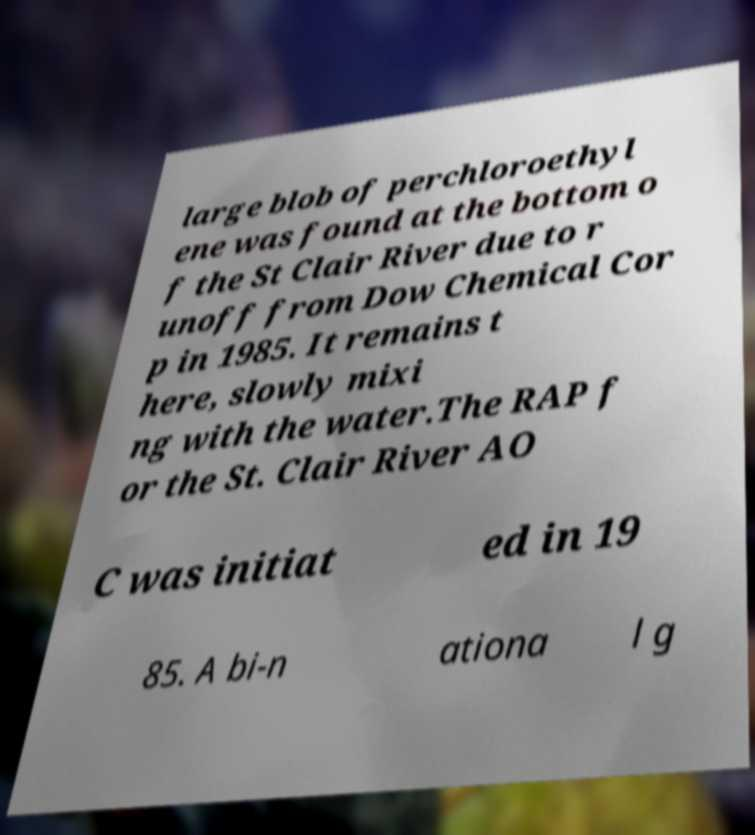There's text embedded in this image that I need extracted. Can you transcribe it verbatim? large blob of perchloroethyl ene was found at the bottom o f the St Clair River due to r unoff from Dow Chemical Cor p in 1985. It remains t here, slowly mixi ng with the water.The RAP f or the St. Clair River AO C was initiat ed in 19 85. A bi-n ationa l g 